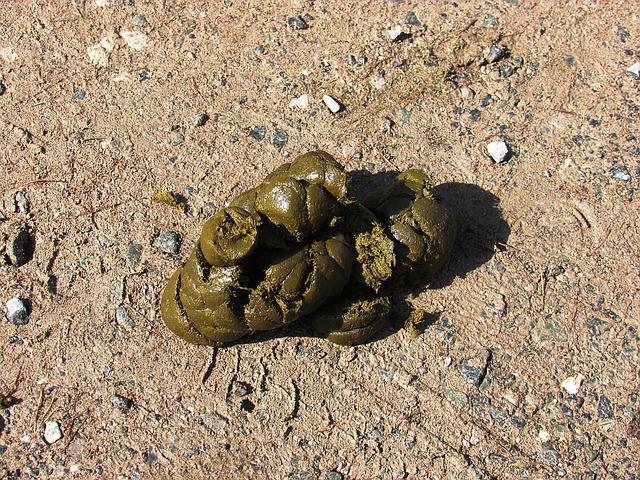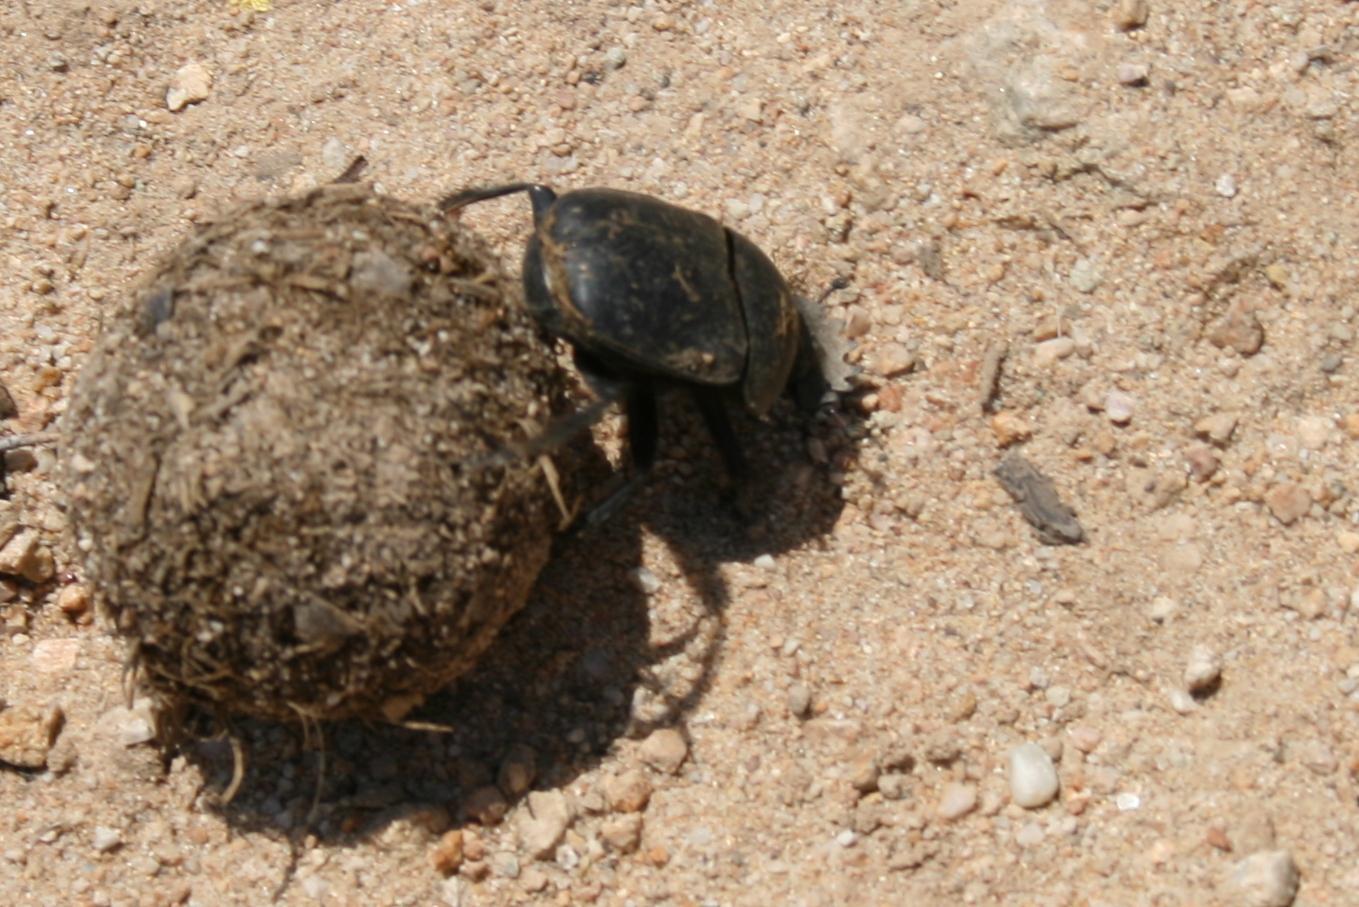The first image is the image on the left, the second image is the image on the right. Assess this claim about the two images: "Two beetles are crawling on the ground in the image on the left.". Correct or not? Answer yes or no. No. The first image is the image on the left, the second image is the image on the right. For the images displayed, is the sentence "There's no more than one dung beetle in the right image." factually correct? Answer yes or no. Yes. 